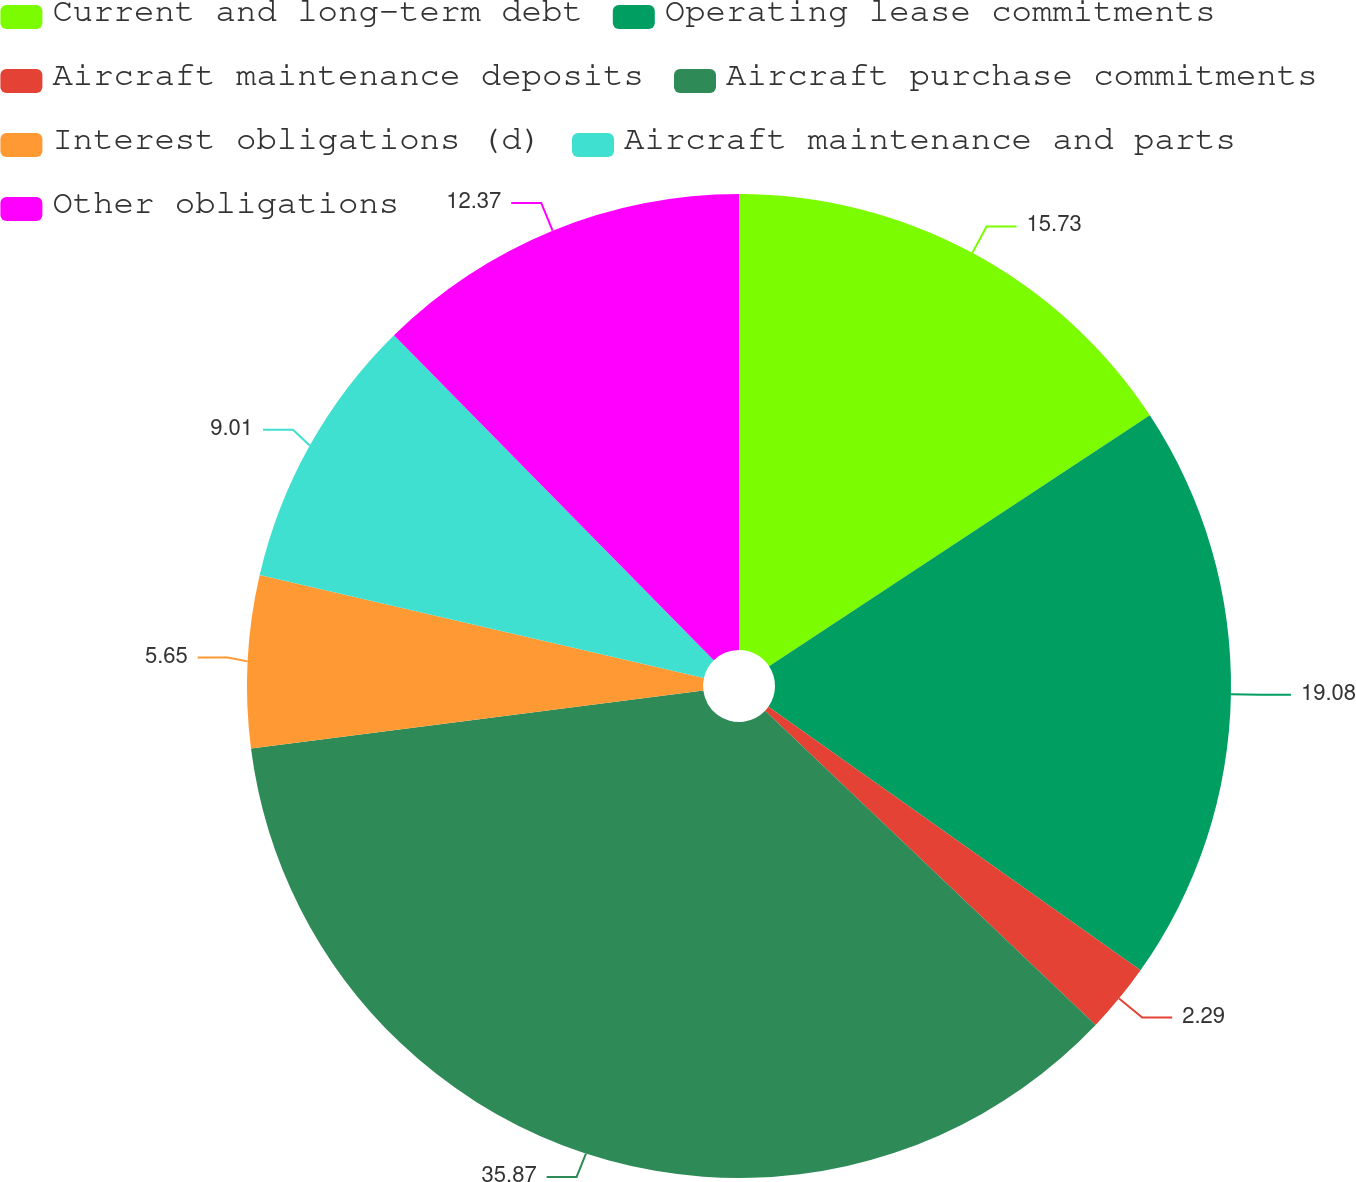Convert chart. <chart><loc_0><loc_0><loc_500><loc_500><pie_chart><fcel>Current and long-term debt<fcel>Operating lease commitments<fcel>Aircraft maintenance deposits<fcel>Aircraft purchase commitments<fcel>Interest obligations (d)<fcel>Aircraft maintenance and parts<fcel>Other obligations<nl><fcel>15.73%<fcel>19.08%<fcel>2.29%<fcel>35.88%<fcel>5.65%<fcel>9.01%<fcel>12.37%<nl></chart> 